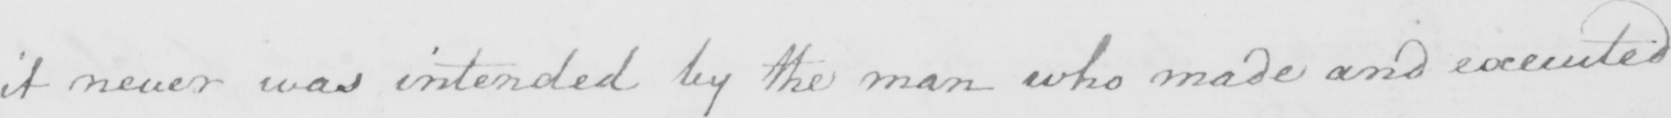Transcribe the text shown in this historical manuscript line. it never was intended by the man who made and executed 